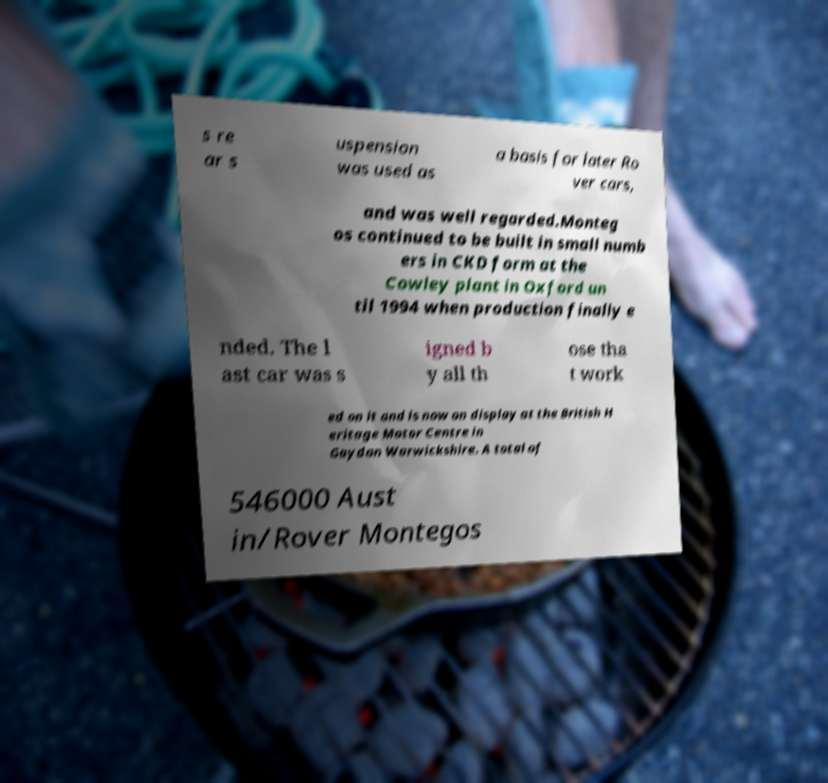There's text embedded in this image that I need extracted. Can you transcribe it verbatim? s re ar s uspension was used as a basis for later Ro ver cars, and was well regarded.Monteg os continued to be built in small numb ers in CKD form at the Cowley plant in Oxford un til 1994 when production finally e nded. The l ast car was s igned b y all th ose tha t work ed on it and is now on display at the British H eritage Motor Centre in Gaydon Warwickshire. A total of 546000 Aust in/Rover Montegos 